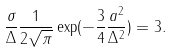<formula> <loc_0><loc_0><loc_500><loc_500>\frac { \sigma } { \Delta } \frac { 1 } { 2 \sqrt { \pi } } \exp ( - \frac { 3 } { 4 } \frac { a ^ { 2 } } { \Delta ^ { 2 } } ) = 3 .</formula> 